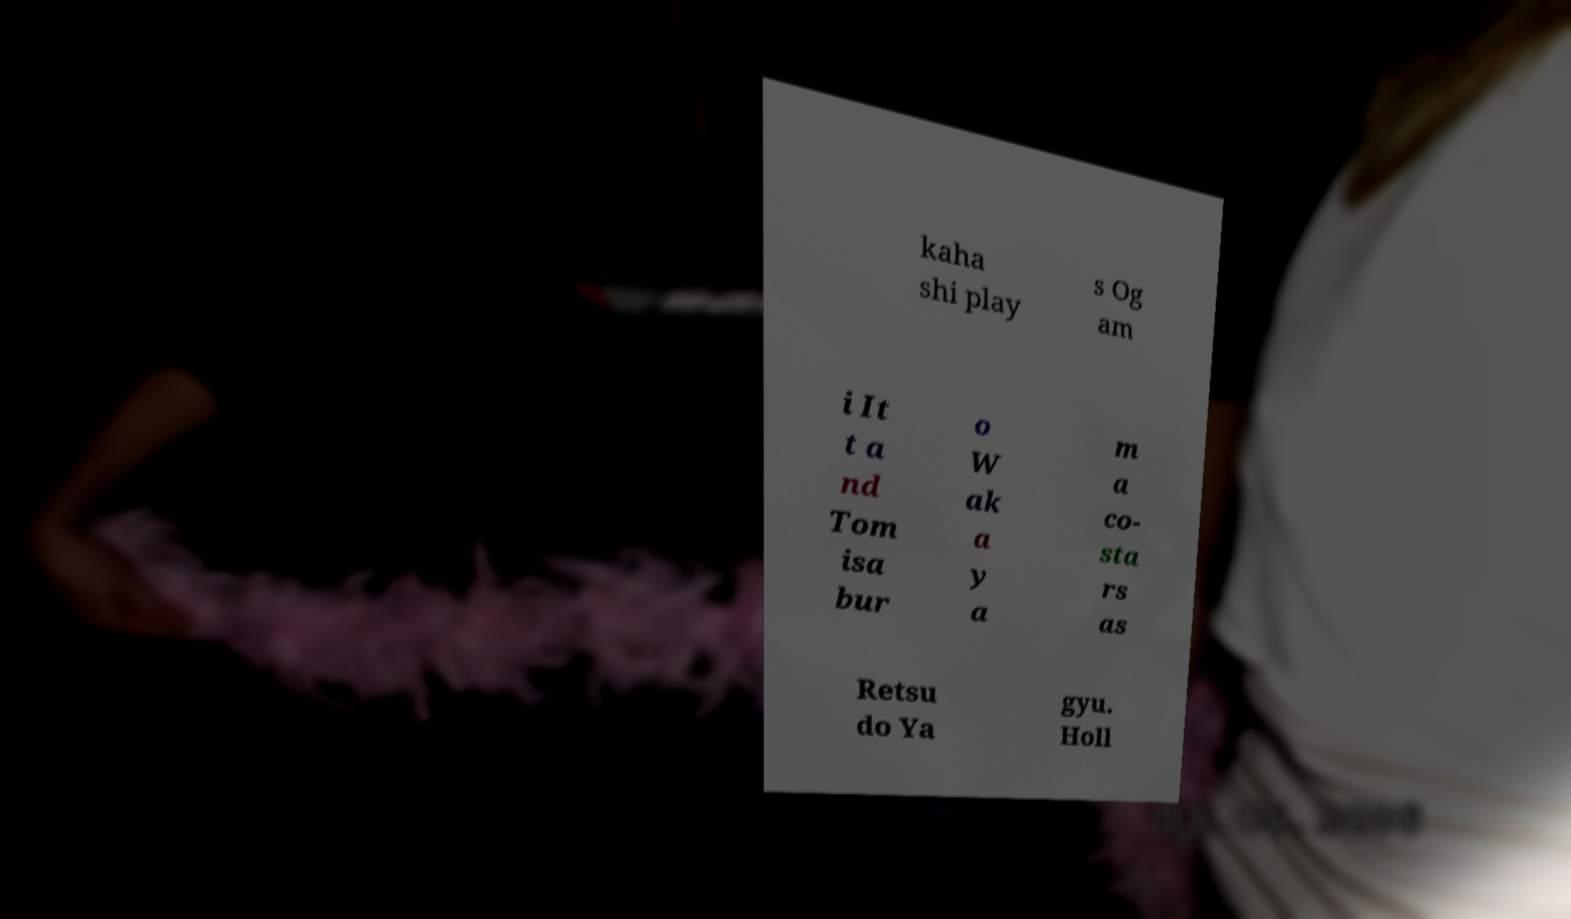Could you extract and type out the text from this image? kaha shi play s Og am i It t a nd Tom isa bur o W ak a y a m a co- sta rs as Retsu do Ya gyu. Holl 